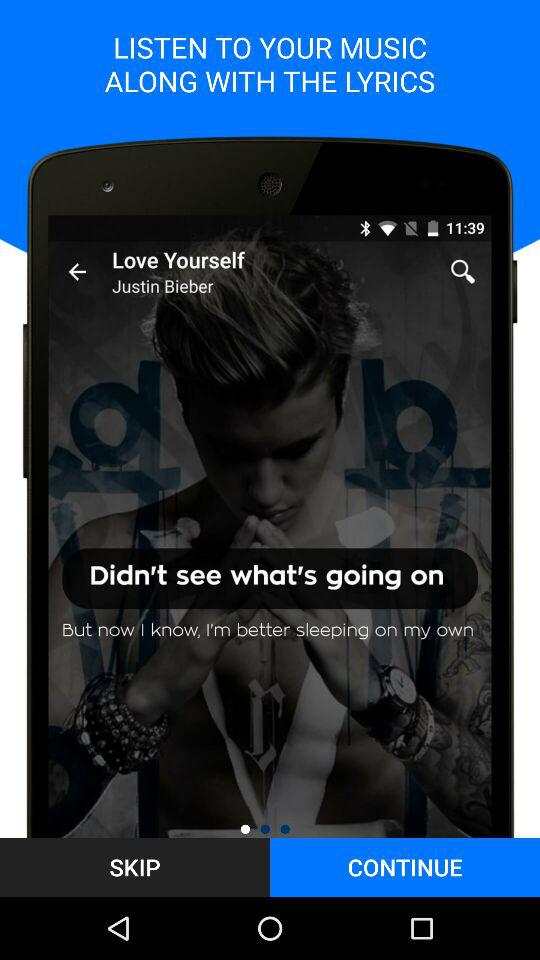How many lines of lyrics are there?
Answer the question using a single word or phrase. 2 